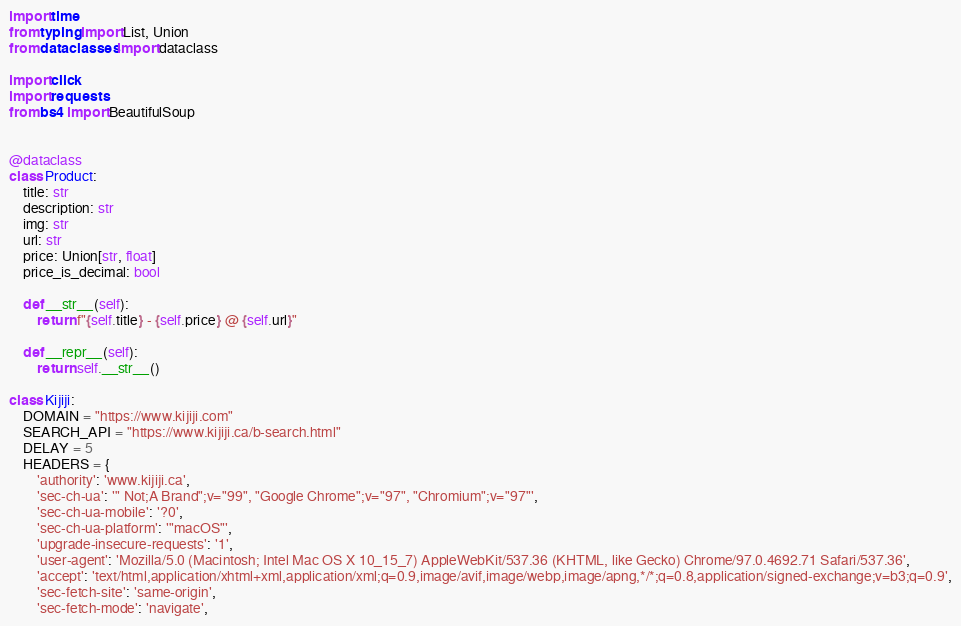<code> <loc_0><loc_0><loc_500><loc_500><_Python_>import time
from typing import List, Union
from dataclasses import dataclass

import click
import requests
from bs4 import BeautifulSoup


@dataclass
class Product:
    title: str
    description: str
    img: str
    url: str
    price: Union[str, float]
    price_is_decimal: bool
        
    def __str__(self):
        return f"{self.title} - {self.price} @ {self.url}"
    
    def __repr__(self):
        return self.__str__()
    
class Kijiji:    
    DOMAIN = "https://www.kijiji.com"
    SEARCH_API = "https://www.kijiji.ca/b-search.html"
    DELAY = 5
    HEADERS = {
        'authority': 'www.kijiji.ca',
        'sec-ch-ua': '" Not;A Brand";v="99", "Google Chrome";v="97", "Chromium";v="97"',
        'sec-ch-ua-mobile': '?0',
        'sec-ch-ua-platform': '"macOS"',
        'upgrade-insecure-requests': '1',
        'user-agent': 'Mozilla/5.0 (Macintosh; Intel Mac OS X 10_15_7) AppleWebKit/537.36 (KHTML, like Gecko) Chrome/97.0.4692.71 Safari/537.36',
        'accept': 'text/html,application/xhtml+xml,application/xml;q=0.9,image/avif,image/webp,image/apng,*/*;q=0.8,application/signed-exchange;v=b3;q=0.9',
        'sec-fetch-site': 'same-origin',
        'sec-fetch-mode': 'navigate',</code> 